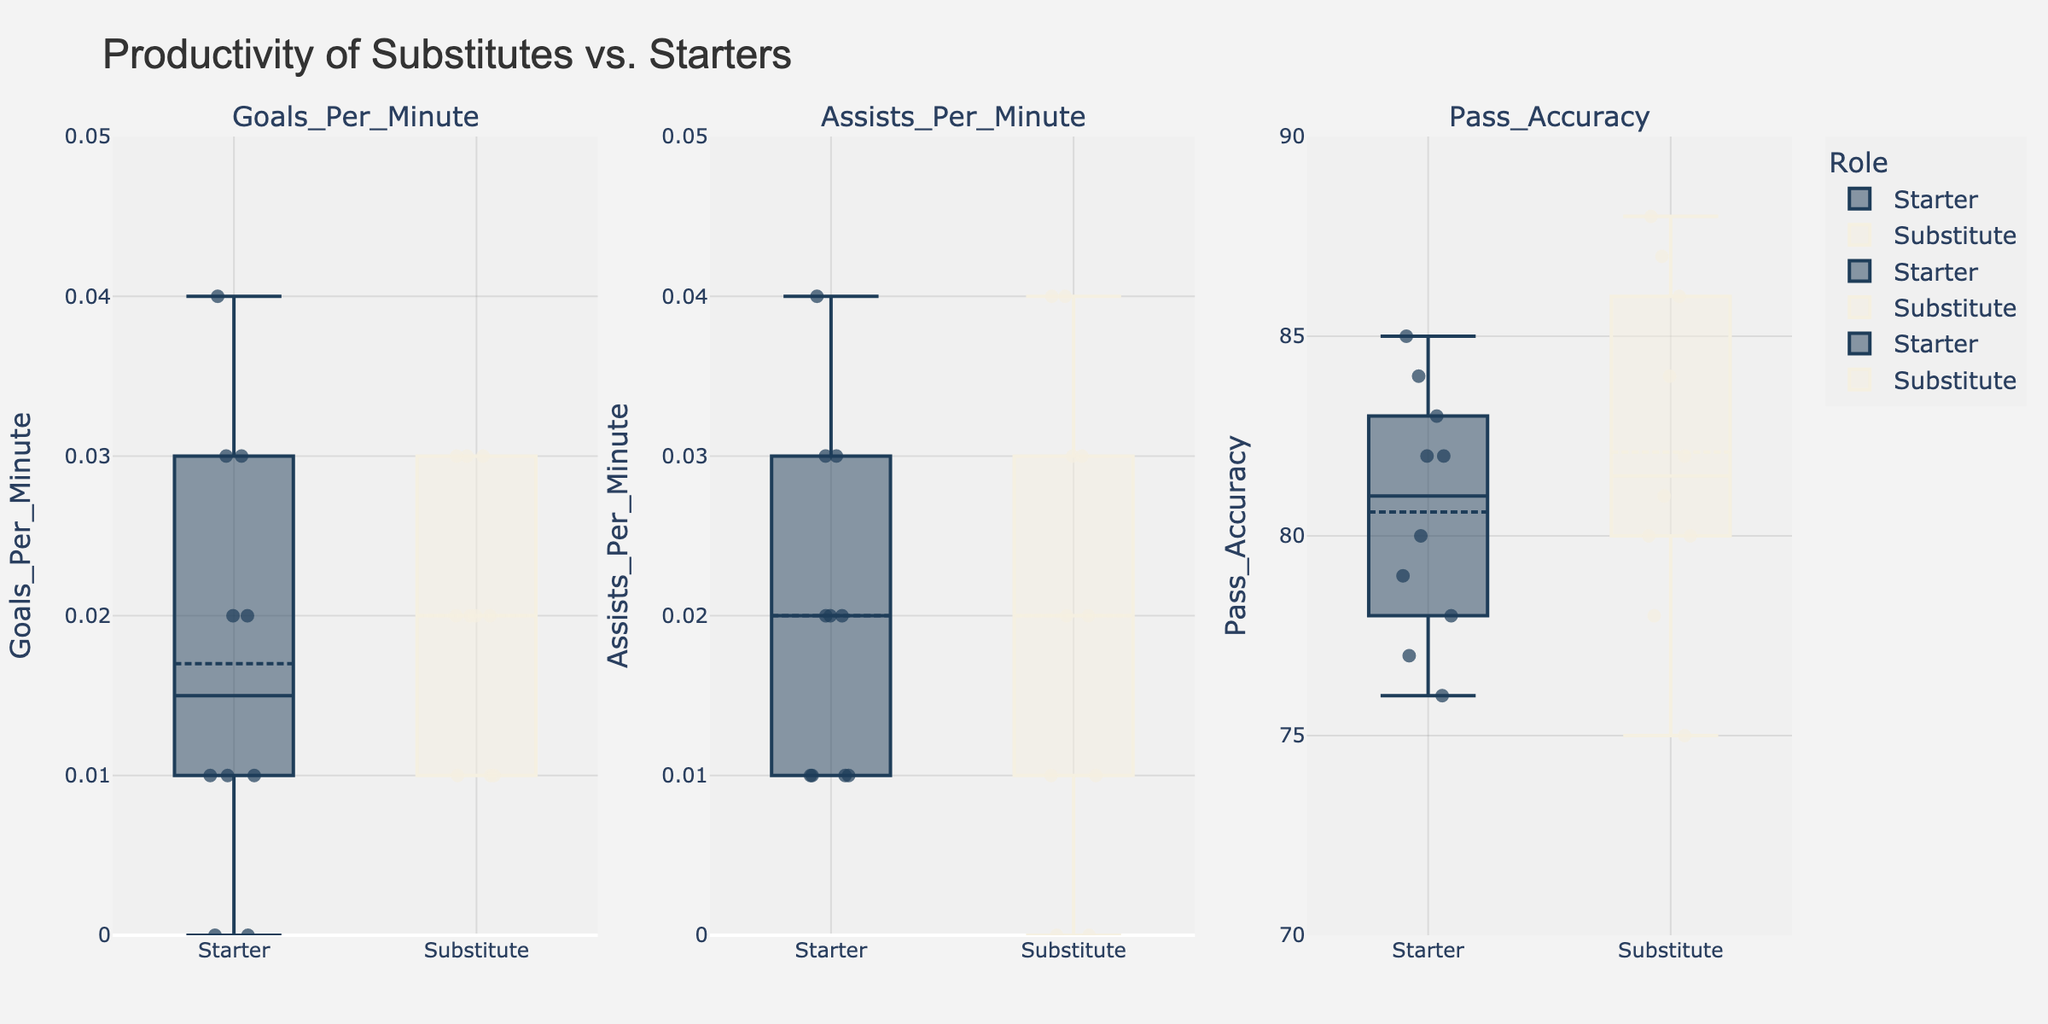What is the title of the figure? The title of the figure can be found at the top of the chart. It usually summarizes the main point of the figure in a few words. In this case, it indicates what the figure is about.
Answer: Productivity of Substitutes vs. Starters What are the metrics shown in the subplots? The metrics can be identified by looking at the titles of each individual subplot. These titles typically denote the different performance measures being analyzed.
Answer: Goals Per Minute, Assists Per Minute, Pass Accuracy What role shows a higher median for 'Goals Per Minute'? The median value is typically indicated by the center line within each box plot. By comparing the center lines in the 'Goals Per Minute' subplot for both roles, we can identify which one is higher.
Answer: Substitute How does the pass accuracy of starters compare to substitutes? By looking at the 'Pass Accuracy' subplot, we can compare the box plots for both roles. The comparison involves noting where most of the data points lie and where the medians are positioned.
Answer: Starters generally have lower pass accuracy compared to substitutes Which role has more variability in 'Assists Per Minute'? Variability in a box plot is indicated by the length of the whiskers and the spread of the outliers. By checking these elements in the 'Assists Per Minute' subplot, we can determine which role shows more variability.
Answer: Substitute In which metric do starters perform better on average? To determine this, we'll look at the median lines of the box plots and identify where the starter's box plot has a higher median than the substitute's. Generally, the 'Goals Per Minute' and 'Assists Per Minute' metrics should be evaluated.
Answer: Goals Per Minute (slightly) Are there any anomalies or outliers in the 'Pass Accuracy' data for either role? Anomalies or outliers in a box plot are represented by points that fall outside of the whiskers. Checking the 'Pass Accuracy' subplot for such points can help in identifying anomalies.
Answer: No significant outliers Which player has the highest difference in 'Pass Accuracy' between roles? This involves comparing the 'Pass Accuracy' values for each player in both roles and calculating the difference. The player with the highest absolute difference is the one we are looking for.
Answer: Gerard Deulofeu In the 'Goals Per Minute' subplot, which role shows a more consistent performance? A more consistent performance is usually indicated by a smaller interquartile range (the height of the box) and shorter whiskers. By comparing these elements in the 'Goals Per Minute', we can determine which role is more consistent.
Answer: Starter 